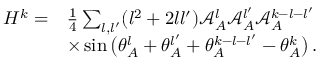<formula> <loc_0><loc_0><loc_500><loc_500>\begin{array} { r l } { H ^ { k } = } & { \frac { 1 } { 4 } \sum _ { { l } , { l ^ { \prime } } } ( { l } ^ { 2 } + 2 { l } { l ^ { \prime } } ) \mathcal { A } _ { A } ^ { l } \mathcal { A } _ { A } ^ { l ^ { \prime } } \mathcal { A } _ { A } ^ { k - { l } - { l ^ { \prime } } } } \\ & { \times \sin \left ( \theta _ { A } ^ { l } + \theta _ { A } ^ { l ^ { \prime } } + \theta _ { A } ^ { k - { l } - { l ^ { \prime } } } - \theta _ { A } ^ { k } \right ) \, . } \end{array}</formula> 